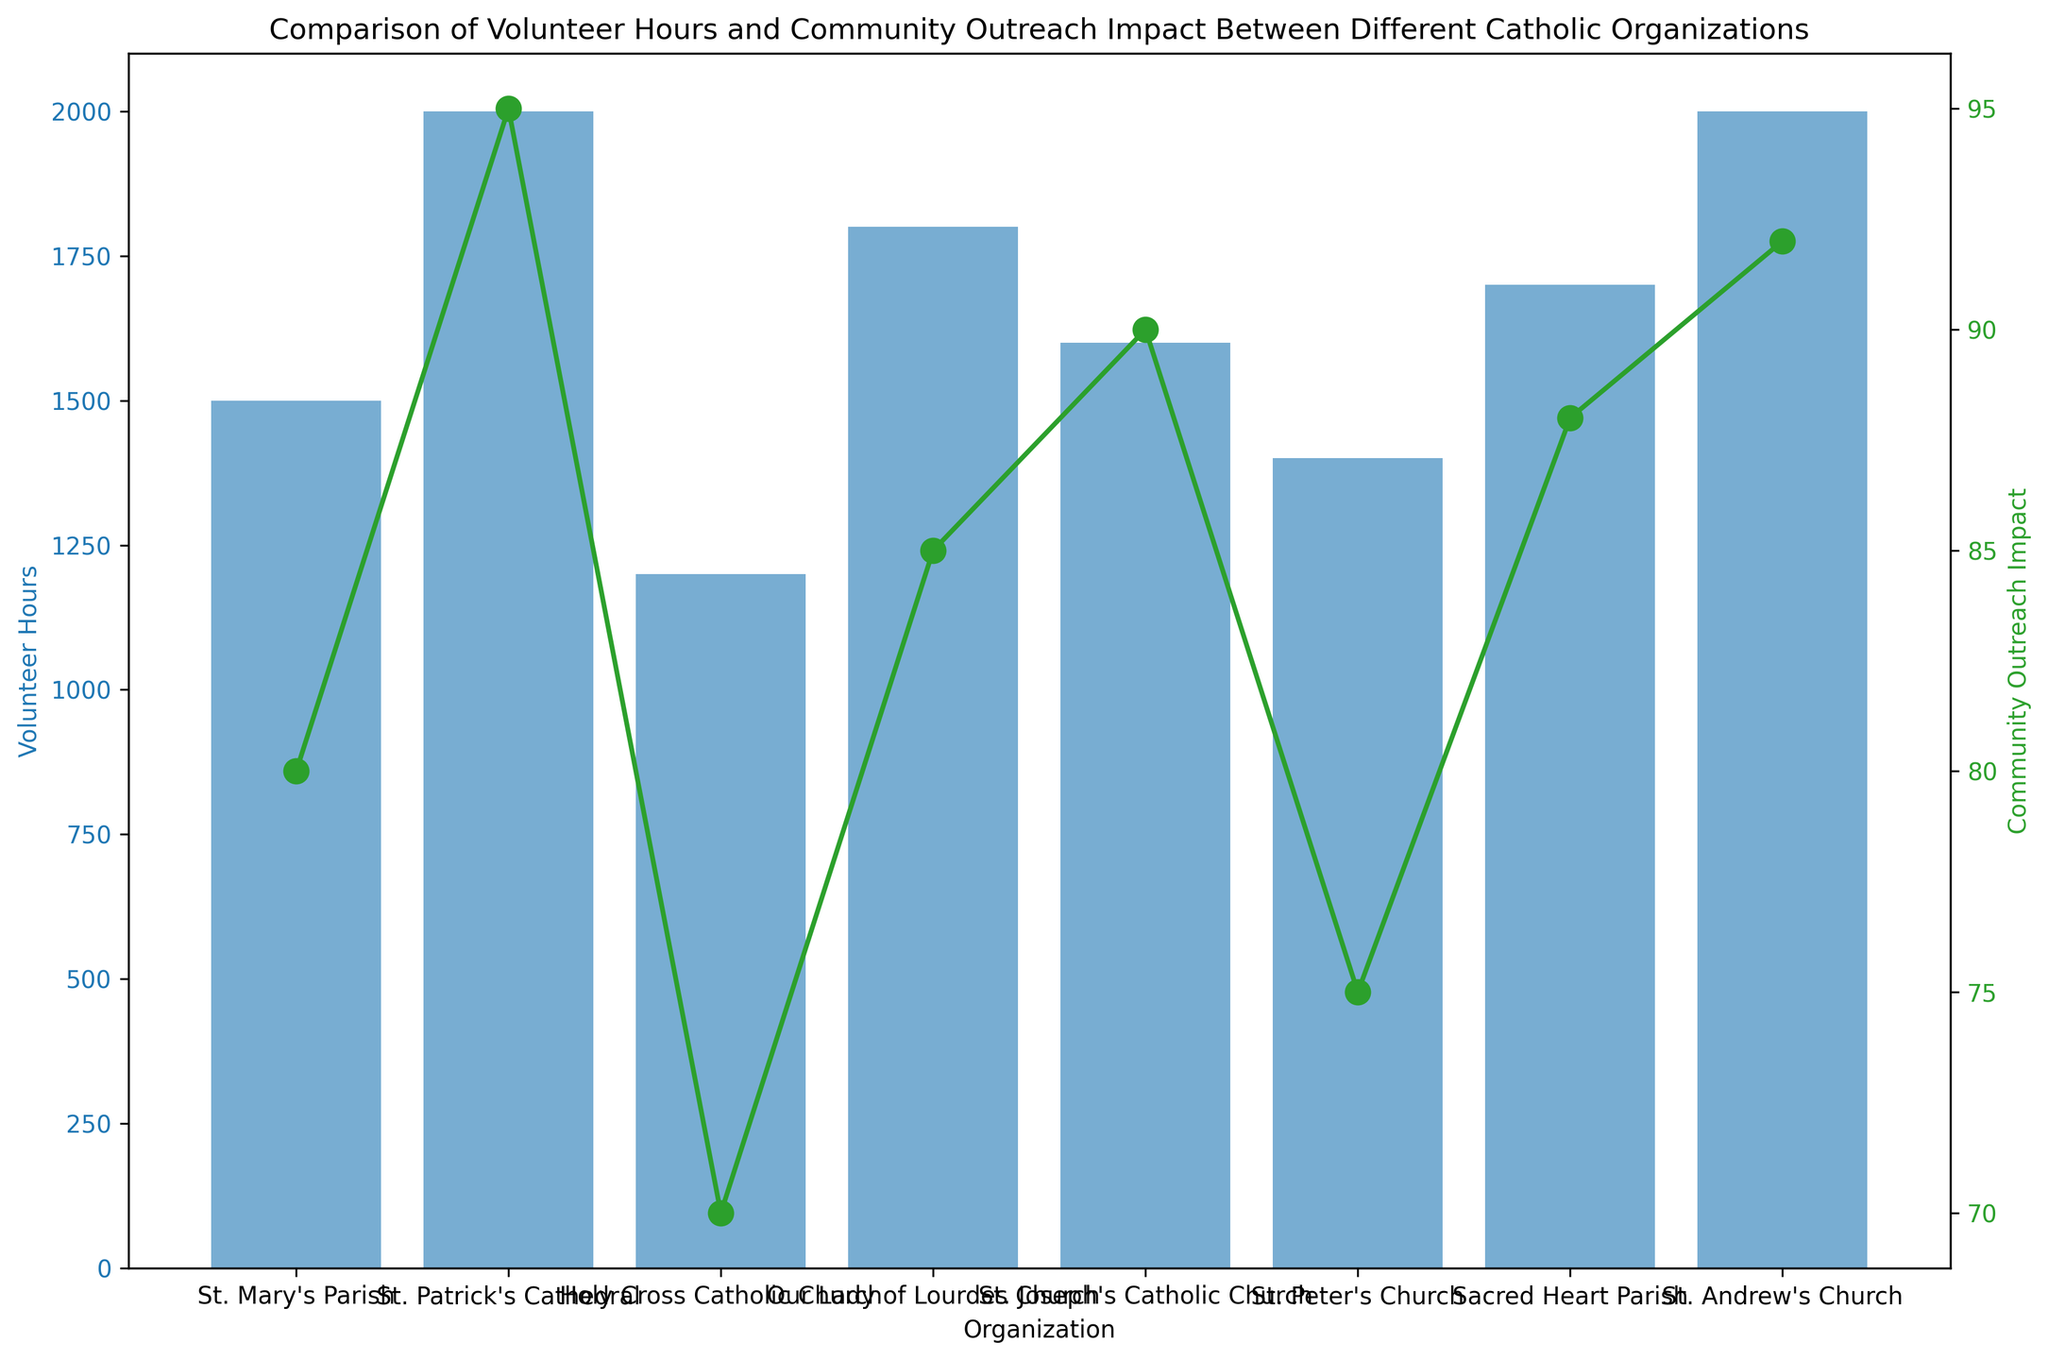Which organization logged the highest number of volunteer hours? Among the organizations illustrated in the figure, locate the tallest blue bar. The highest bar corresponds to St. Patrick's Cathedral and St. Andrew's Church, both logging the same number of volunteer hours.
Answer: St. Patrick's Cathedral and St. Andrew's Church What is the range of Community Outreach Impact values across all organizations? To determine the range, identify the maximum and minimum values of the green line representing Community Outreach Impact. The maximum value is 95 (St. Patrick's Cathedral) and the minimum is 70 (Holy Cross Catholic Church). The range is obtained by subtracting the minimum from the maximum: 95 - 70.
Answer: 25 Which organization has the lowest Community Outreach Impact? Observe the green markers on the figure and note that the lowest value is for Holy Cross Catholic Church, with an impact score of 70.
Answer: Holy Cross Catholic Church How does the Volunteer Hours of St. Mary's Parish compare to St. Joseph's Catholic Church? Look at the heights of the blue bars for St. Mary's Parish and St. Joseph's Catholic Church. St. Mary's Parish has 1500 volunteer hours, whereas St. Joseph's Catholic Church has 1600 volunteer hours. St. Joseph's Catholic Church has 100 more volunteer hours than St. Mary's Parish.
Answer: St. Mary's Parish has 100 fewer volunteer hours What is the median value of Community Outreach Impact? List the Community Outreach Impact values in ascending order (70, 75, 80, 85, 88, 90, 92, 95). The median is the average of the 4th and 5th values since there are an even number of data points: (85 + 88) / 2.
Answer: 86.5 By how much do the volunteer hours of Holy Cross Catholic Church differ from Our Lady of Lourdes Church? Find the heights of the blue bars for both organizations. Holy Cross Catholic Church logged 1200 hours and Our Lady of Lourdes Church logged 1800 hours. Subtract the smaller value from the larger one: 1800 - 1200.
Answer: 600 hours Which organization has a Community Outreach Impact of exactly 90? Look at the green markers and find the value where the line hits 90. This corresponds to St. Joseph's Catholic Church.
Answer: St. Joseph's Catholic Church Is there any organization that has both high volunteer hours (>=1700) and high Community Outreach Impact (>=90)? Investigate the blue bars and green line to spot organizations meeting both criteria. St. Patrick's Cathedral, Sacred Heart Parish, and St. Andrew's Church all meet these thresholds.
Answer: St. Patrick's Cathedral, Sacred Heart Parish, and St. Andrew's Church 